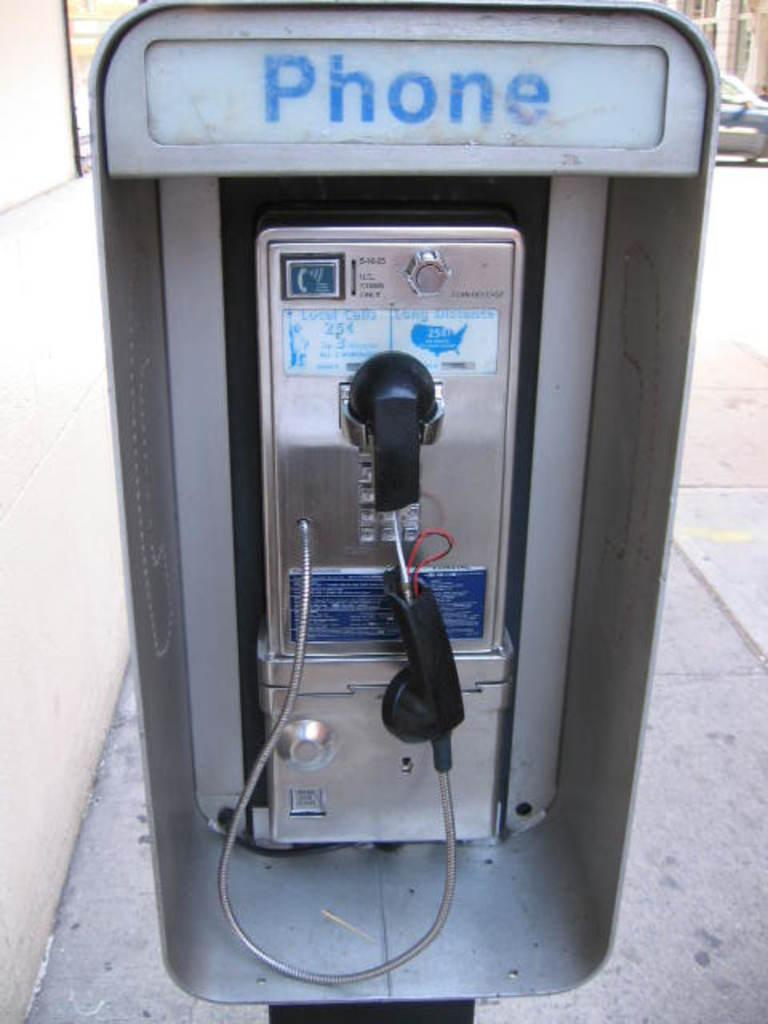<image>
Provide a brief description of the given image. An old fashioned phone booth with Phone written on it 